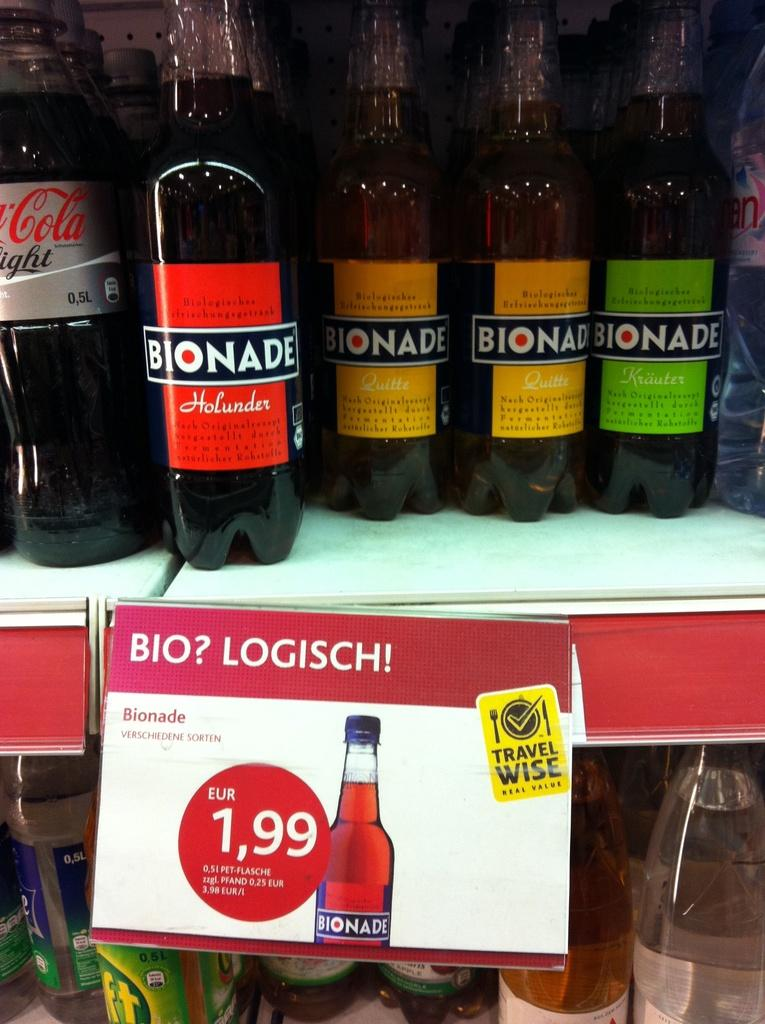<image>
Write a terse but informative summary of the picture. different varieties of bionade on a shelf with a tag showing price of eur 1,99 